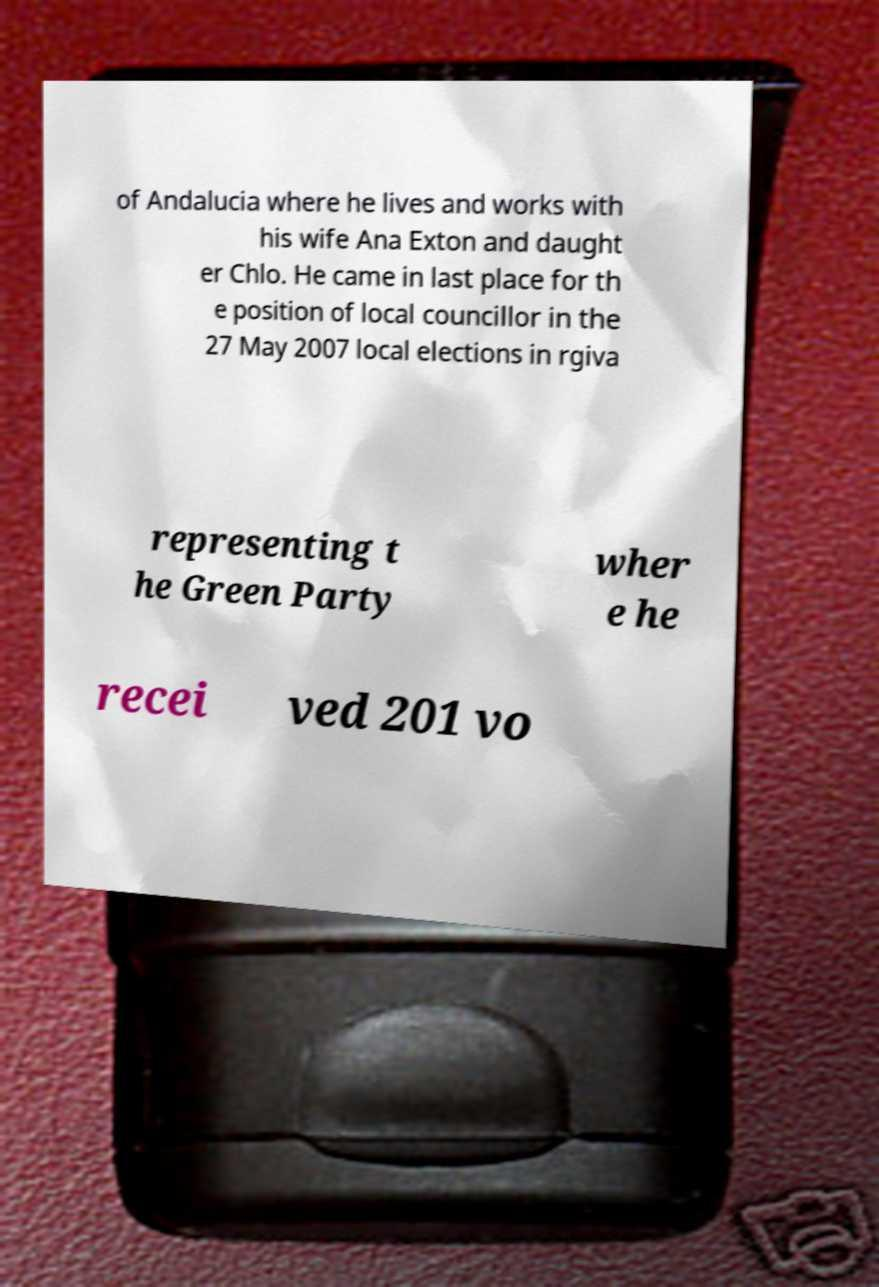Can you accurately transcribe the text from the provided image for me? of Andalucia where he lives and works with his wife Ana Exton and daught er Chlo. He came in last place for th e position of local councillor in the 27 May 2007 local elections in rgiva representing t he Green Party wher e he recei ved 201 vo 